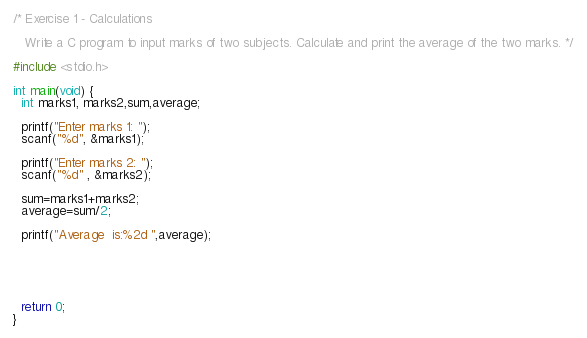Convert code to text. <code><loc_0><loc_0><loc_500><loc_500><_C_>/* Exercise 1 - Calculations

   Write a C program to input marks of two subjects. Calculate and print the average of the two marks. */

#include <stdio.h>

int main(void) {
  int marks1, marks2,sum,average;
  
  printf("Enter marks 1: ");
  scanf("%d", &marks1);

  printf("Enter marks 2: ");
  scanf("%d" , &marks2);

  sum=marks1+marks2;
  average=sum/2;

  printf("Average  is:%2d ",average);

  



  return 0;
}

</code> 